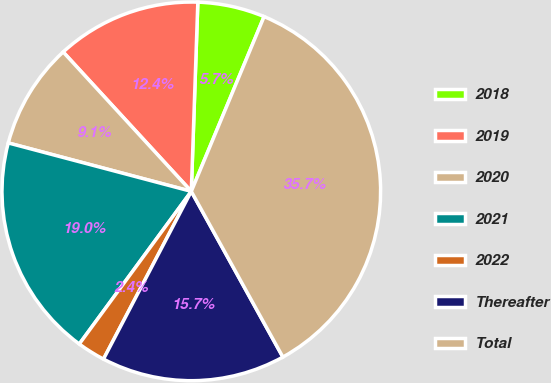<chart> <loc_0><loc_0><loc_500><loc_500><pie_chart><fcel>2018<fcel>2019<fcel>2020<fcel>2021<fcel>2022<fcel>Thereafter<fcel>Total<nl><fcel>5.73%<fcel>12.38%<fcel>9.05%<fcel>19.04%<fcel>2.4%<fcel>15.71%<fcel>35.68%<nl></chart> 